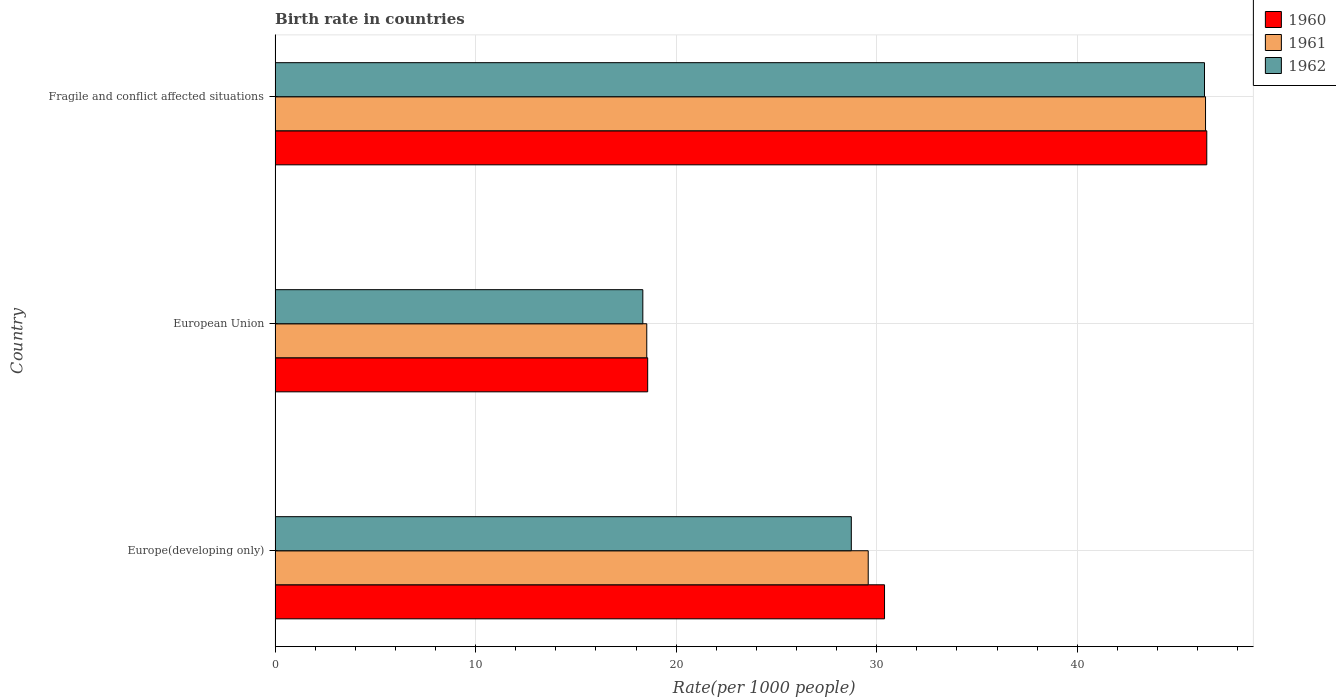How many different coloured bars are there?
Give a very brief answer. 3. Are the number of bars per tick equal to the number of legend labels?
Keep it short and to the point. Yes. Are the number of bars on each tick of the Y-axis equal?
Your answer should be very brief. Yes. What is the label of the 1st group of bars from the top?
Give a very brief answer. Fragile and conflict affected situations. What is the birth rate in 1961 in Fragile and conflict affected situations?
Provide a short and direct response. 46.4. Across all countries, what is the maximum birth rate in 1960?
Your response must be concise. 46.46. Across all countries, what is the minimum birth rate in 1960?
Your answer should be very brief. 18.58. In which country was the birth rate in 1961 maximum?
Keep it short and to the point. Fragile and conflict affected situations. In which country was the birth rate in 1961 minimum?
Provide a succinct answer. European Union. What is the total birth rate in 1962 in the graph?
Ensure brevity in your answer.  93.42. What is the difference between the birth rate in 1961 in Europe(developing only) and that in European Union?
Offer a very short reply. 11.04. What is the difference between the birth rate in 1960 in Europe(developing only) and the birth rate in 1962 in Fragile and conflict affected situations?
Give a very brief answer. -15.95. What is the average birth rate in 1961 per country?
Ensure brevity in your answer.  31.5. What is the difference between the birth rate in 1962 and birth rate in 1961 in Fragile and conflict affected situations?
Offer a very short reply. -0.05. What is the ratio of the birth rate in 1961 in Europe(developing only) to that in Fragile and conflict affected situations?
Your response must be concise. 0.64. Is the birth rate in 1960 in Europe(developing only) less than that in European Union?
Provide a succinct answer. No. What is the difference between the highest and the second highest birth rate in 1961?
Provide a short and direct response. 16.82. What is the difference between the highest and the lowest birth rate in 1960?
Offer a very short reply. 27.88. In how many countries, is the birth rate in 1960 greater than the average birth rate in 1960 taken over all countries?
Offer a very short reply. 1. Is it the case that in every country, the sum of the birth rate in 1962 and birth rate in 1961 is greater than the birth rate in 1960?
Ensure brevity in your answer.  Yes. How many bars are there?
Your response must be concise. 9. Are all the bars in the graph horizontal?
Provide a short and direct response. Yes. Does the graph contain any zero values?
Make the answer very short. No. Does the graph contain grids?
Offer a terse response. Yes. Where does the legend appear in the graph?
Keep it short and to the point. Top right. What is the title of the graph?
Provide a succinct answer. Birth rate in countries. What is the label or title of the X-axis?
Your answer should be very brief. Rate(per 1000 people). What is the Rate(per 1000 people) in 1960 in Europe(developing only)?
Your response must be concise. 30.39. What is the Rate(per 1000 people) in 1961 in Europe(developing only)?
Make the answer very short. 29.58. What is the Rate(per 1000 people) of 1962 in Europe(developing only)?
Offer a very short reply. 28.73. What is the Rate(per 1000 people) of 1960 in European Union?
Offer a terse response. 18.58. What is the Rate(per 1000 people) in 1961 in European Union?
Your answer should be very brief. 18.53. What is the Rate(per 1000 people) of 1962 in European Union?
Provide a short and direct response. 18.34. What is the Rate(per 1000 people) of 1960 in Fragile and conflict affected situations?
Make the answer very short. 46.46. What is the Rate(per 1000 people) of 1961 in Fragile and conflict affected situations?
Provide a short and direct response. 46.4. What is the Rate(per 1000 people) in 1962 in Fragile and conflict affected situations?
Your answer should be compact. 46.34. Across all countries, what is the maximum Rate(per 1000 people) in 1960?
Offer a very short reply. 46.46. Across all countries, what is the maximum Rate(per 1000 people) in 1961?
Ensure brevity in your answer.  46.4. Across all countries, what is the maximum Rate(per 1000 people) in 1962?
Give a very brief answer. 46.34. Across all countries, what is the minimum Rate(per 1000 people) of 1960?
Your answer should be compact. 18.58. Across all countries, what is the minimum Rate(per 1000 people) in 1961?
Keep it short and to the point. 18.53. Across all countries, what is the minimum Rate(per 1000 people) in 1962?
Provide a succinct answer. 18.34. What is the total Rate(per 1000 people) in 1960 in the graph?
Keep it short and to the point. 95.43. What is the total Rate(per 1000 people) of 1961 in the graph?
Keep it short and to the point. 94.51. What is the total Rate(per 1000 people) of 1962 in the graph?
Give a very brief answer. 93.42. What is the difference between the Rate(per 1000 people) of 1960 in Europe(developing only) and that in European Union?
Ensure brevity in your answer.  11.81. What is the difference between the Rate(per 1000 people) in 1961 in Europe(developing only) and that in European Union?
Provide a short and direct response. 11.04. What is the difference between the Rate(per 1000 people) of 1962 in Europe(developing only) and that in European Union?
Your answer should be very brief. 10.4. What is the difference between the Rate(per 1000 people) in 1960 in Europe(developing only) and that in Fragile and conflict affected situations?
Give a very brief answer. -16.07. What is the difference between the Rate(per 1000 people) in 1961 in Europe(developing only) and that in Fragile and conflict affected situations?
Your answer should be very brief. -16.82. What is the difference between the Rate(per 1000 people) of 1962 in Europe(developing only) and that in Fragile and conflict affected situations?
Provide a succinct answer. -17.61. What is the difference between the Rate(per 1000 people) in 1960 in European Union and that in Fragile and conflict affected situations?
Make the answer very short. -27.88. What is the difference between the Rate(per 1000 people) in 1961 in European Union and that in Fragile and conflict affected situations?
Make the answer very short. -27.86. What is the difference between the Rate(per 1000 people) of 1962 in European Union and that in Fragile and conflict affected situations?
Your answer should be compact. -28.01. What is the difference between the Rate(per 1000 people) in 1960 in Europe(developing only) and the Rate(per 1000 people) in 1961 in European Union?
Your answer should be very brief. 11.86. What is the difference between the Rate(per 1000 people) of 1960 in Europe(developing only) and the Rate(per 1000 people) of 1962 in European Union?
Your answer should be very brief. 12.05. What is the difference between the Rate(per 1000 people) of 1961 in Europe(developing only) and the Rate(per 1000 people) of 1962 in European Union?
Make the answer very short. 11.24. What is the difference between the Rate(per 1000 people) in 1960 in Europe(developing only) and the Rate(per 1000 people) in 1961 in Fragile and conflict affected situations?
Provide a short and direct response. -16.01. What is the difference between the Rate(per 1000 people) in 1960 in Europe(developing only) and the Rate(per 1000 people) in 1962 in Fragile and conflict affected situations?
Make the answer very short. -15.95. What is the difference between the Rate(per 1000 people) in 1961 in Europe(developing only) and the Rate(per 1000 people) in 1962 in Fragile and conflict affected situations?
Offer a terse response. -16.77. What is the difference between the Rate(per 1000 people) in 1960 in European Union and the Rate(per 1000 people) in 1961 in Fragile and conflict affected situations?
Ensure brevity in your answer.  -27.82. What is the difference between the Rate(per 1000 people) of 1960 in European Union and the Rate(per 1000 people) of 1962 in Fragile and conflict affected situations?
Offer a terse response. -27.77. What is the difference between the Rate(per 1000 people) in 1961 in European Union and the Rate(per 1000 people) in 1962 in Fragile and conflict affected situations?
Ensure brevity in your answer.  -27.81. What is the average Rate(per 1000 people) of 1960 per country?
Ensure brevity in your answer.  31.81. What is the average Rate(per 1000 people) in 1961 per country?
Your answer should be very brief. 31.5. What is the average Rate(per 1000 people) in 1962 per country?
Ensure brevity in your answer.  31.14. What is the difference between the Rate(per 1000 people) of 1960 and Rate(per 1000 people) of 1961 in Europe(developing only)?
Make the answer very short. 0.81. What is the difference between the Rate(per 1000 people) in 1960 and Rate(per 1000 people) in 1962 in Europe(developing only)?
Provide a succinct answer. 1.66. What is the difference between the Rate(per 1000 people) in 1961 and Rate(per 1000 people) in 1962 in Europe(developing only)?
Offer a terse response. 0.84. What is the difference between the Rate(per 1000 people) in 1960 and Rate(per 1000 people) in 1961 in European Union?
Offer a very short reply. 0.05. What is the difference between the Rate(per 1000 people) in 1960 and Rate(per 1000 people) in 1962 in European Union?
Offer a very short reply. 0.24. What is the difference between the Rate(per 1000 people) in 1961 and Rate(per 1000 people) in 1962 in European Union?
Your answer should be compact. 0.2. What is the difference between the Rate(per 1000 people) of 1960 and Rate(per 1000 people) of 1961 in Fragile and conflict affected situations?
Offer a terse response. 0.06. What is the difference between the Rate(per 1000 people) in 1960 and Rate(per 1000 people) in 1962 in Fragile and conflict affected situations?
Provide a short and direct response. 0.11. What is the difference between the Rate(per 1000 people) of 1961 and Rate(per 1000 people) of 1962 in Fragile and conflict affected situations?
Your response must be concise. 0.05. What is the ratio of the Rate(per 1000 people) of 1960 in Europe(developing only) to that in European Union?
Your answer should be very brief. 1.64. What is the ratio of the Rate(per 1000 people) in 1961 in Europe(developing only) to that in European Union?
Provide a succinct answer. 1.6. What is the ratio of the Rate(per 1000 people) of 1962 in Europe(developing only) to that in European Union?
Your response must be concise. 1.57. What is the ratio of the Rate(per 1000 people) of 1960 in Europe(developing only) to that in Fragile and conflict affected situations?
Provide a succinct answer. 0.65. What is the ratio of the Rate(per 1000 people) of 1961 in Europe(developing only) to that in Fragile and conflict affected situations?
Give a very brief answer. 0.64. What is the ratio of the Rate(per 1000 people) of 1962 in Europe(developing only) to that in Fragile and conflict affected situations?
Give a very brief answer. 0.62. What is the ratio of the Rate(per 1000 people) of 1960 in European Union to that in Fragile and conflict affected situations?
Provide a succinct answer. 0.4. What is the ratio of the Rate(per 1000 people) in 1961 in European Union to that in Fragile and conflict affected situations?
Make the answer very short. 0.4. What is the ratio of the Rate(per 1000 people) in 1962 in European Union to that in Fragile and conflict affected situations?
Ensure brevity in your answer.  0.4. What is the difference between the highest and the second highest Rate(per 1000 people) of 1960?
Your answer should be compact. 16.07. What is the difference between the highest and the second highest Rate(per 1000 people) of 1961?
Make the answer very short. 16.82. What is the difference between the highest and the second highest Rate(per 1000 people) in 1962?
Offer a very short reply. 17.61. What is the difference between the highest and the lowest Rate(per 1000 people) in 1960?
Ensure brevity in your answer.  27.88. What is the difference between the highest and the lowest Rate(per 1000 people) in 1961?
Your answer should be very brief. 27.86. What is the difference between the highest and the lowest Rate(per 1000 people) of 1962?
Keep it short and to the point. 28.01. 